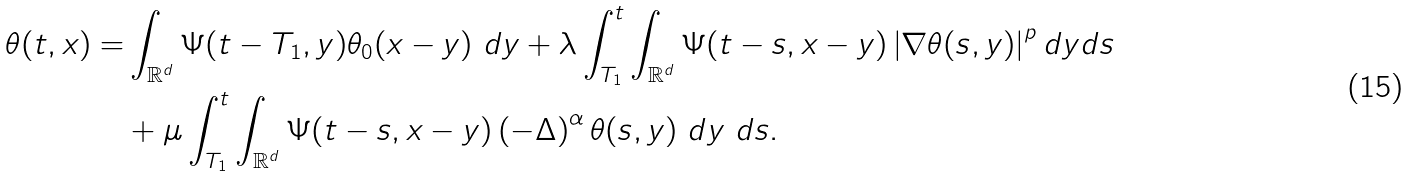<formula> <loc_0><loc_0><loc_500><loc_500>\theta ( t , x ) = & \int _ { \mathbb { R } ^ { d } } \Psi ( t - T _ { 1 } , y ) \theta _ { 0 } ( x - y ) \ d y + \lambda \int _ { T _ { 1 } } ^ { t } \int _ { \mathbb { R } ^ { d } } \Psi ( t - s , x - y ) \left | \nabla \theta ( s , y ) \right | ^ { p } d y d s \\ & + \mu \int _ { T _ { 1 } } ^ { t } \int _ { \mathbb { R } ^ { d } } \Psi ( t - s , x - y ) \left ( - \Delta \right ) ^ { \alpha } \theta ( s , y ) \ d y \ d s .</formula> 